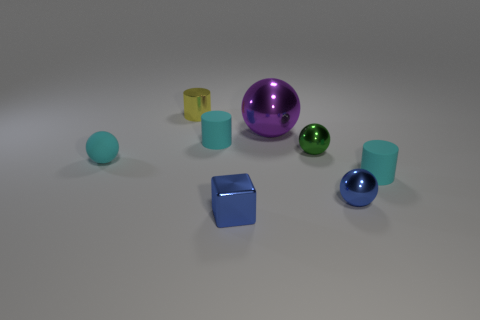Which objects in the image reflect light the most? The large purple sphere and the small blue sphere have highly reflective surfaces, making them stand out as the objects that reflect light the most in the image. 